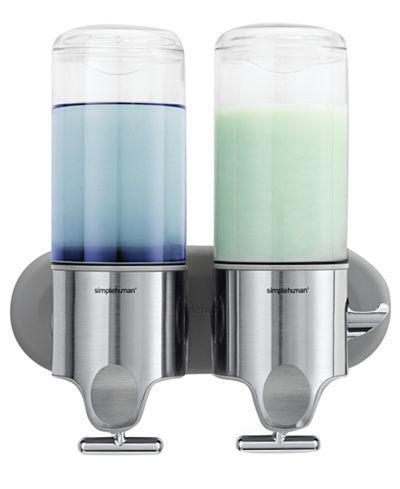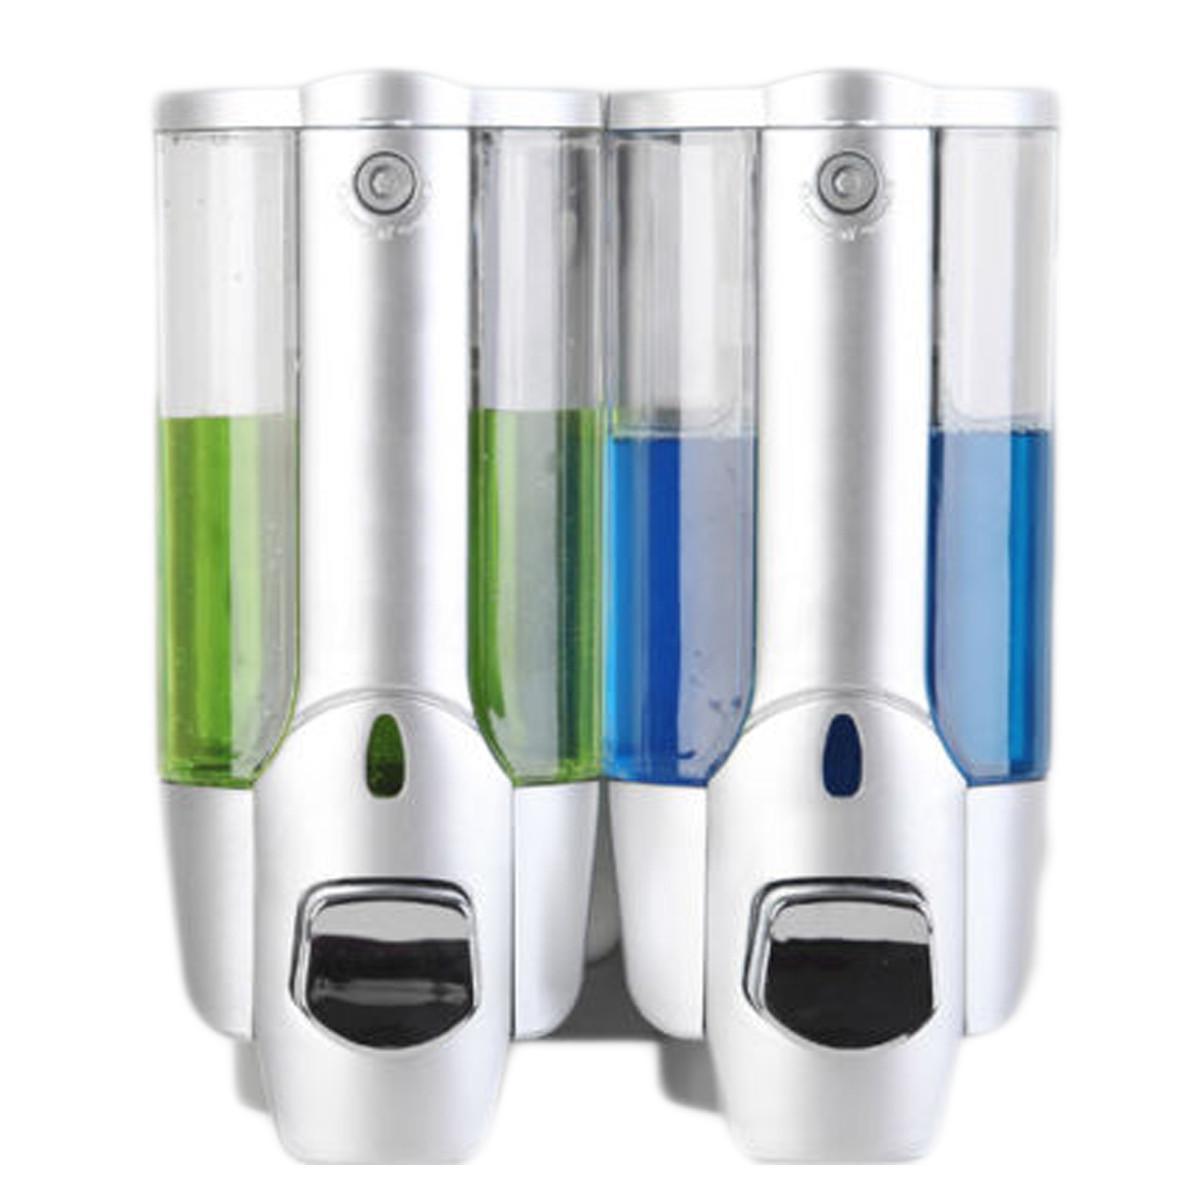The first image is the image on the left, the second image is the image on the right. Examine the images to the left and right. Is the description "There are three dispensers filled with substances in each of the images." accurate? Answer yes or no. No. The first image is the image on the left, the second image is the image on the right. Assess this claim about the two images: "Each image shows three side-by-side dispensers, with at least one containing a bluish substance.". Correct or not? Answer yes or no. No. 